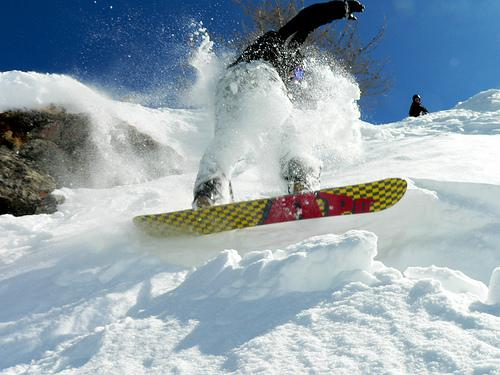Question: where was the photo taken?
Choices:
A. On a mountainside.
B. Outside.
C. At a ski slope.
D. In a field of snow.
Answer with the letter. Answer: C Question: who is snowboarding?
Choices:
A. A person.
B. An athlete.
C. The teenager.
D. The team captain.
Answer with the letter. Answer: A Question: what is blue?
Choices:
A. Water.
B. Sky.
C. Flowers.
D. Boat sails.
Answer with the letter. Answer: B Question: what is yellow and red?
Choices:
A. Jacket.
B. Skis.
C. Snowboard.
D. Ski lift.
Answer with the letter. Answer: C 